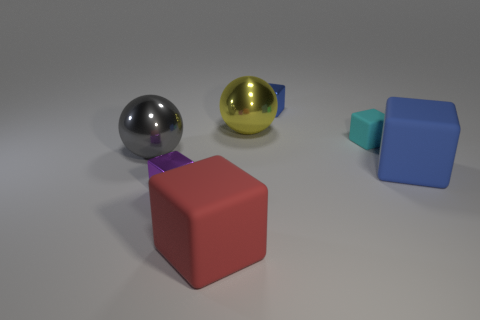How many rubber objects are either blue cubes or large cubes?
Give a very brief answer. 2. There is a big metallic thing to the right of the metal ball that is on the left side of the small purple metal cube; what is its shape?
Make the answer very short. Sphere. Is the number of big red matte cubes on the right side of the yellow ball less than the number of purple things?
Offer a terse response. Yes. What is the shape of the big yellow metal object?
Offer a very short reply. Sphere. What size is the blue cube in front of the gray sphere?
Keep it short and to the point. Large. There is another matte cube that is the same size as the red cube; what is its color?
Your answer should be very brief. Blue. Are there any large blocks that have the same color as the small matte block?
Your response must be concise. No. Is the number of shiny objects in front of the big yellow thing less than the number of large red things behind the big gray metallic ball?
Offer a terse response. No. What is the thing that is both left of the big red object and on the right side of the large gray thing made of?
Provide a succinct answer. Metal. Do the cyan thing and the big shiny object behind the gray thing have the same shape?
Offer a very short reply. No. 